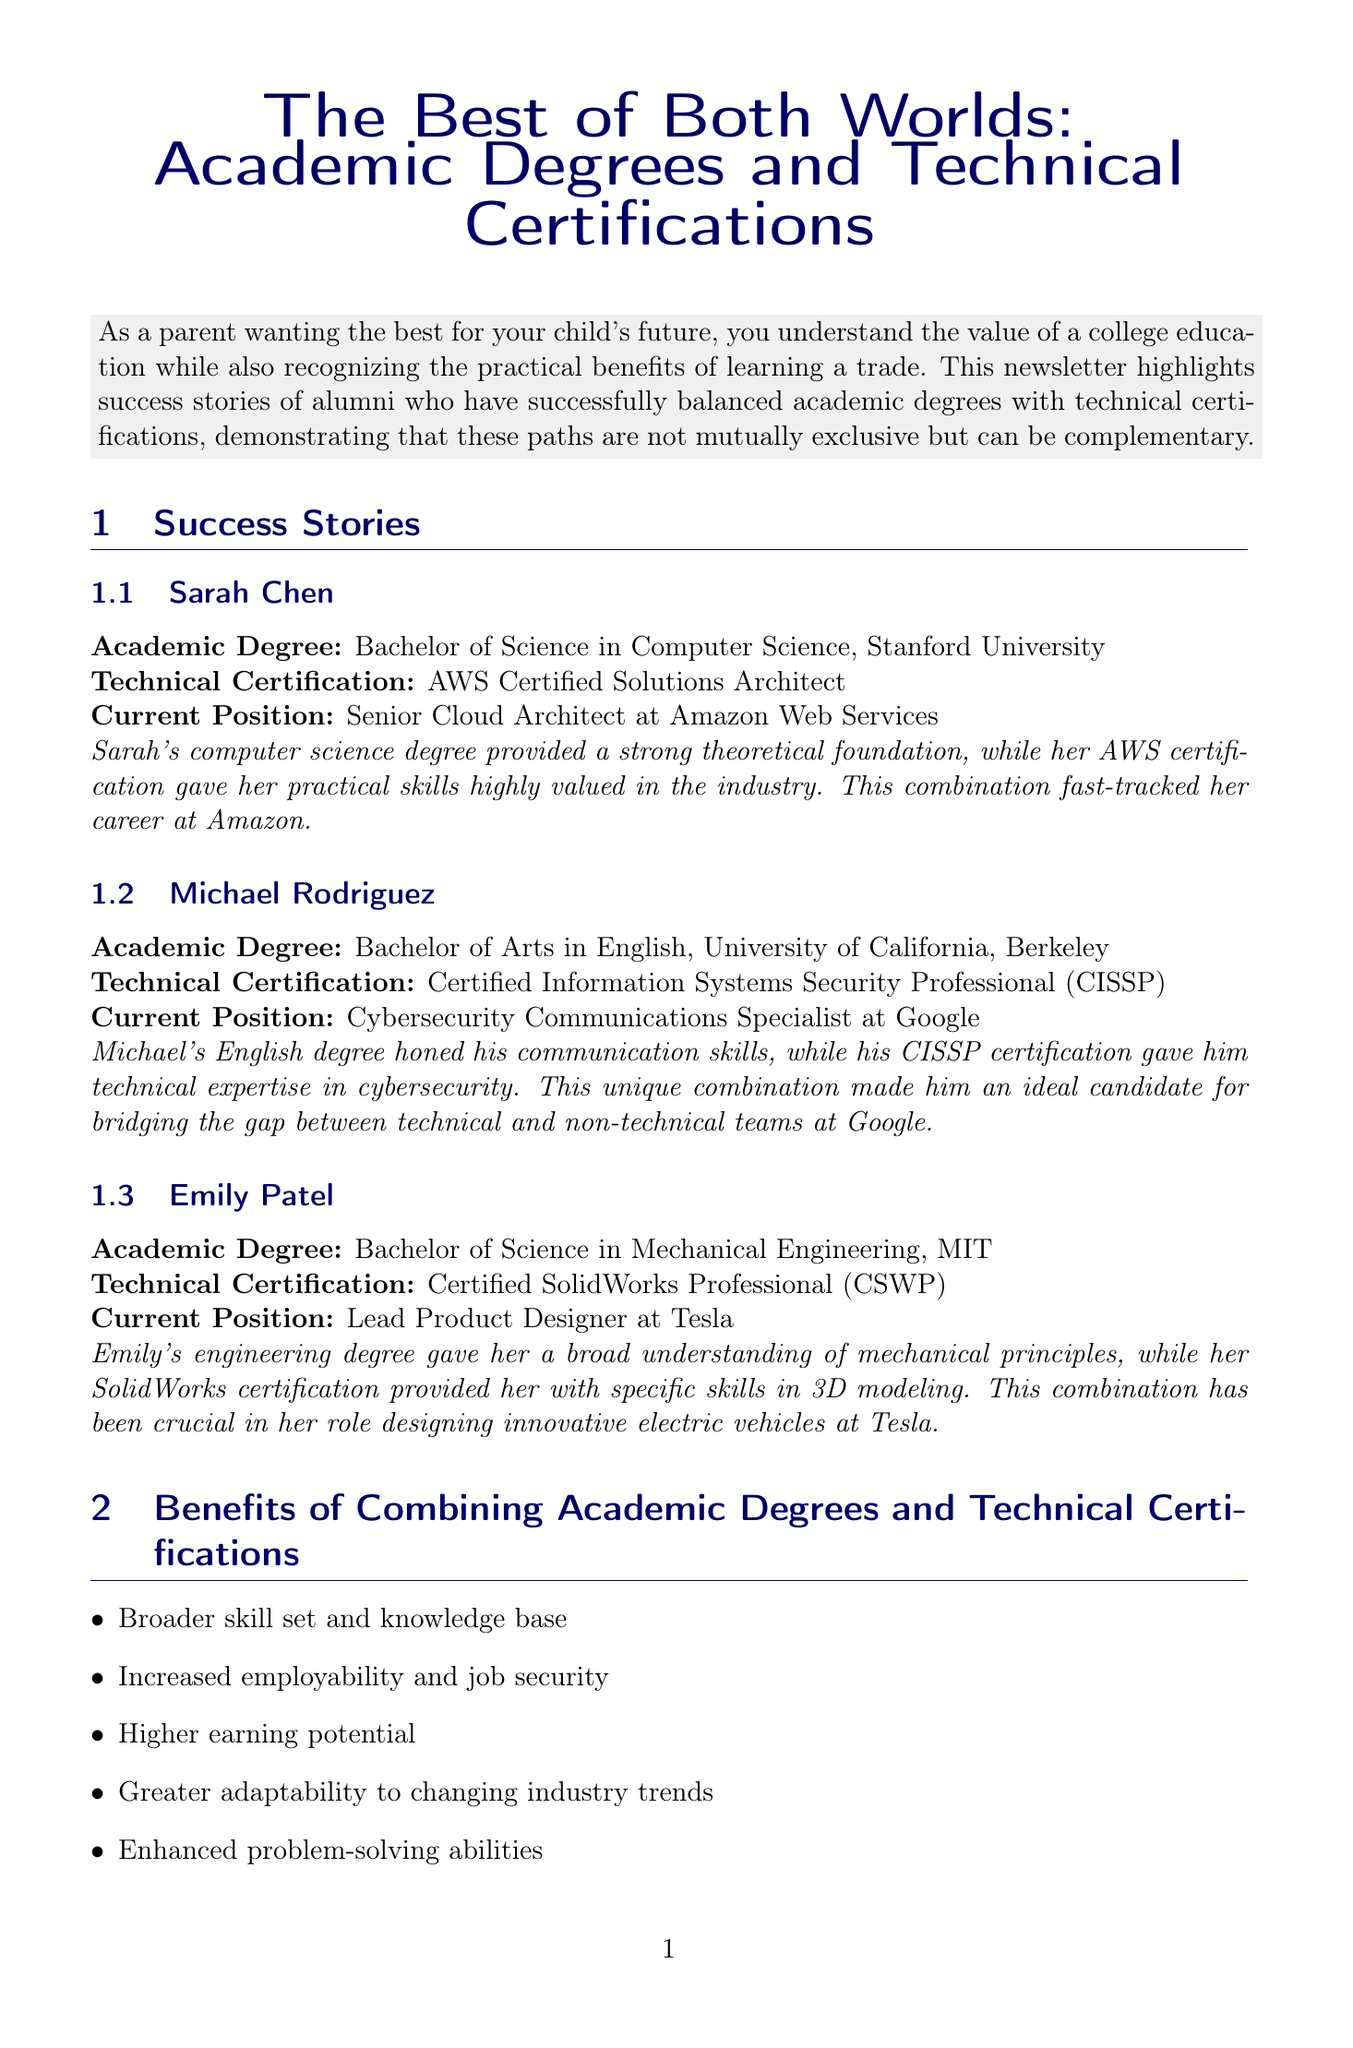what is the title of the newsletter? The title of the newsletter is prominently displayed at the top, indicating the main focus.
Answer: The Best of Both Worlds: Academic Degrees and Technical Certifications who is the current position of Sarah Chen? Sarah Chen's current position is listed under her success story.
Answer: Senior Cloud Architect at Amazon Web Services which university did Michael Rodriguez attend? The university that Michael Rodriguez attended is mentioned in his academic degree section.
Answer: University of California, Berkeley what technical certification does Emily Patel hold? Emily Patel's technical certification is specified in her success story.
Answer: Certified SolidWorks Professional (CSWP) what is one benefit of combining academic degrees and technical certifications? The benefits section lists several advantages, illustrating why this combination is valuable.
Answer: Increased employability and job security how can parents support their child's dual path? One of the tips provided in the article focuses on how parents can aid in this process.
Answer: Encourage exploration of both academic and technical interests how many success stories are highlighted in the newsletter? The number of success stories can be found in the success stories section.
Answer: Three what is the main purpose of the newsletter? The introduction explains the intent behind the document and its relevance to parents.
Answer: To highlight success stories of alumni who balanced academic degrees with technical certifications 